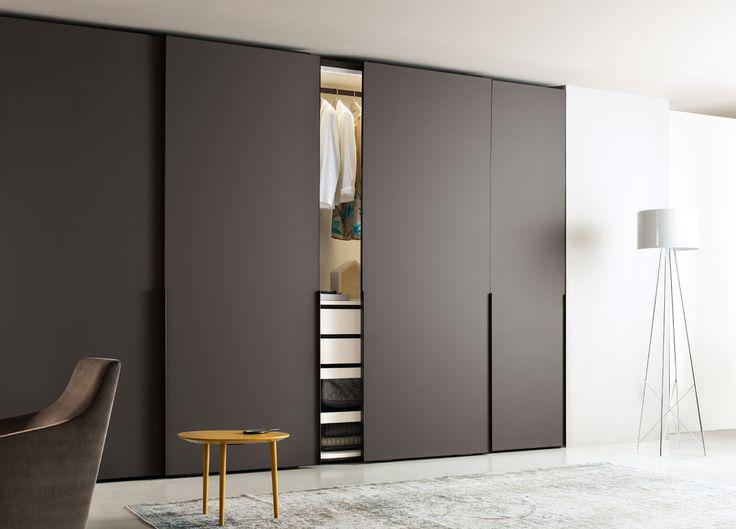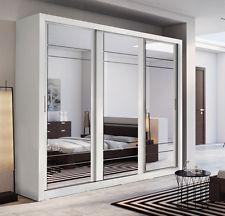The first image is the image on the left, the second image is the image on the right. Given the left and right images, does the statement "An image shows a closed sliding-door unit with at least one mirrored center panel flanked by brown wood panels on the sides." hold true? Answer yes or no. No. The first image is the image on the left, the second image is the image on the right. Considering the images on both sides, is "A plant is near a sliding cabinet in one of the images." valid? Answer yes or no. No. 